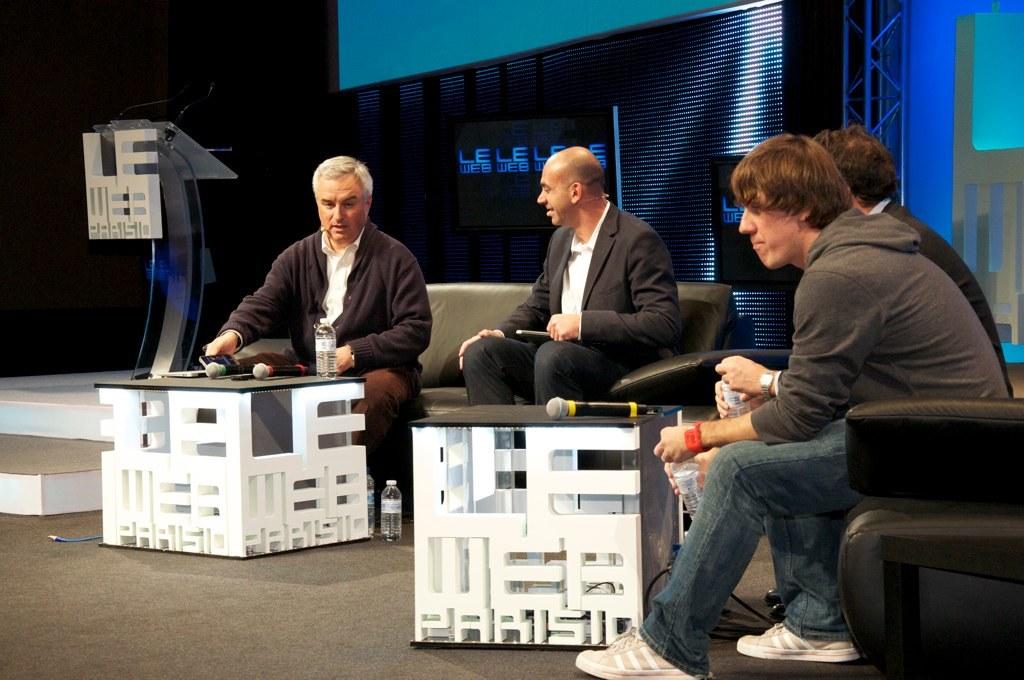What does it say on the monitor in the background?
Your response must be concise. Le web. What is the last word on the cube signs?
Provide a succinct answer. Parisio. 